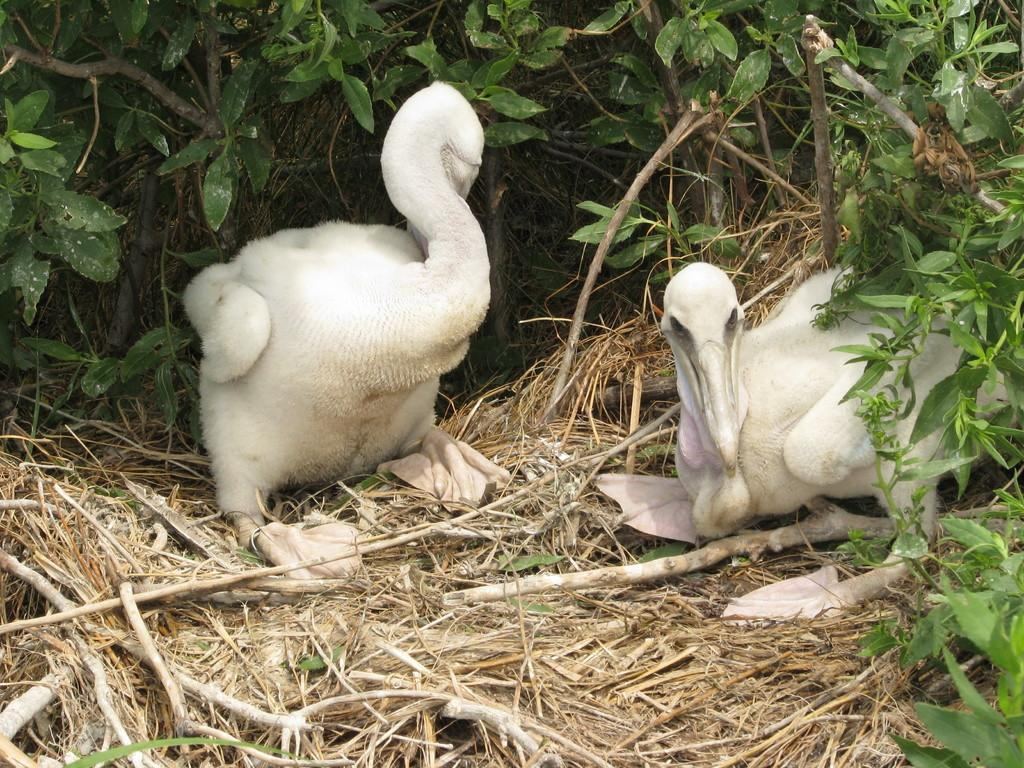What type of animals can be seen in the image? There are birds in the image. What type of vegetation is present in the image? There is dry grass, branches, and leaves in the image. What type of garden can be seen in the image? There is no garden present in the image; it features birds and vegetation. How are the birds playing with each other in the image? The image does not depict the birds playing with each other; they are simply present in the image. 